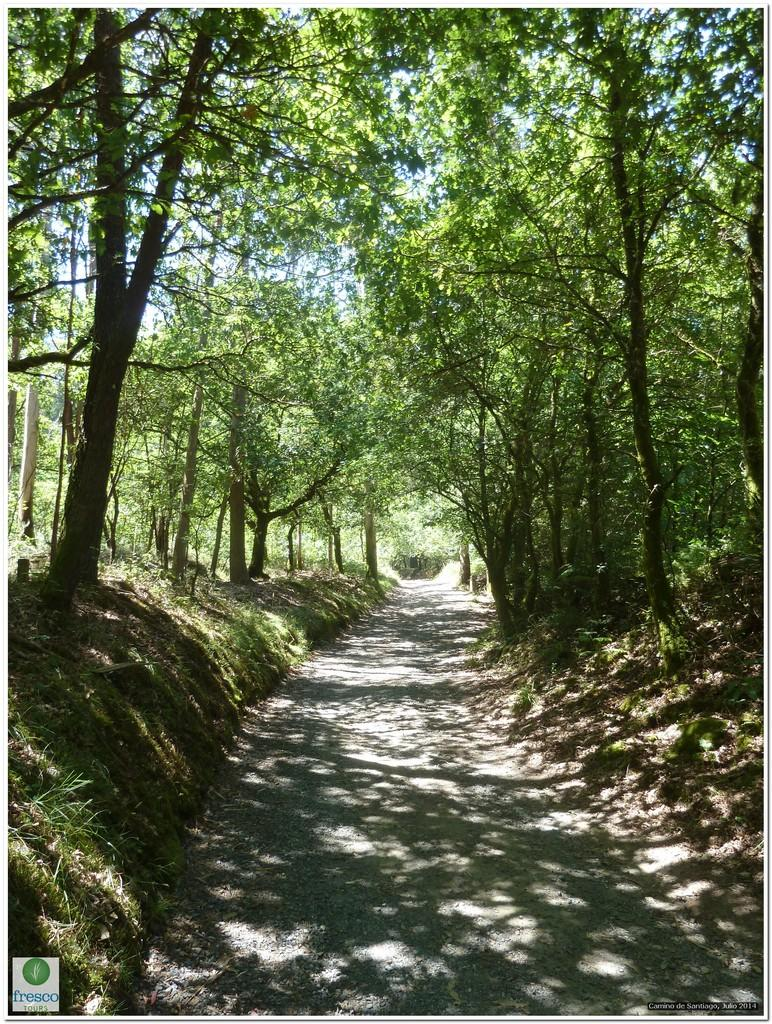What type of surface can be seen in the image? There is a path in the image. What type of vegetation is present in the image? There is grass and trees in the image. What can be seen in the background of the image? The sky is visible in the background of the image. How many chickens are visible in the image? There are no chickens present in the image. What type of vein can be seen in the image? There are no veins visible in the image, as it is a natural outdoor scene. 